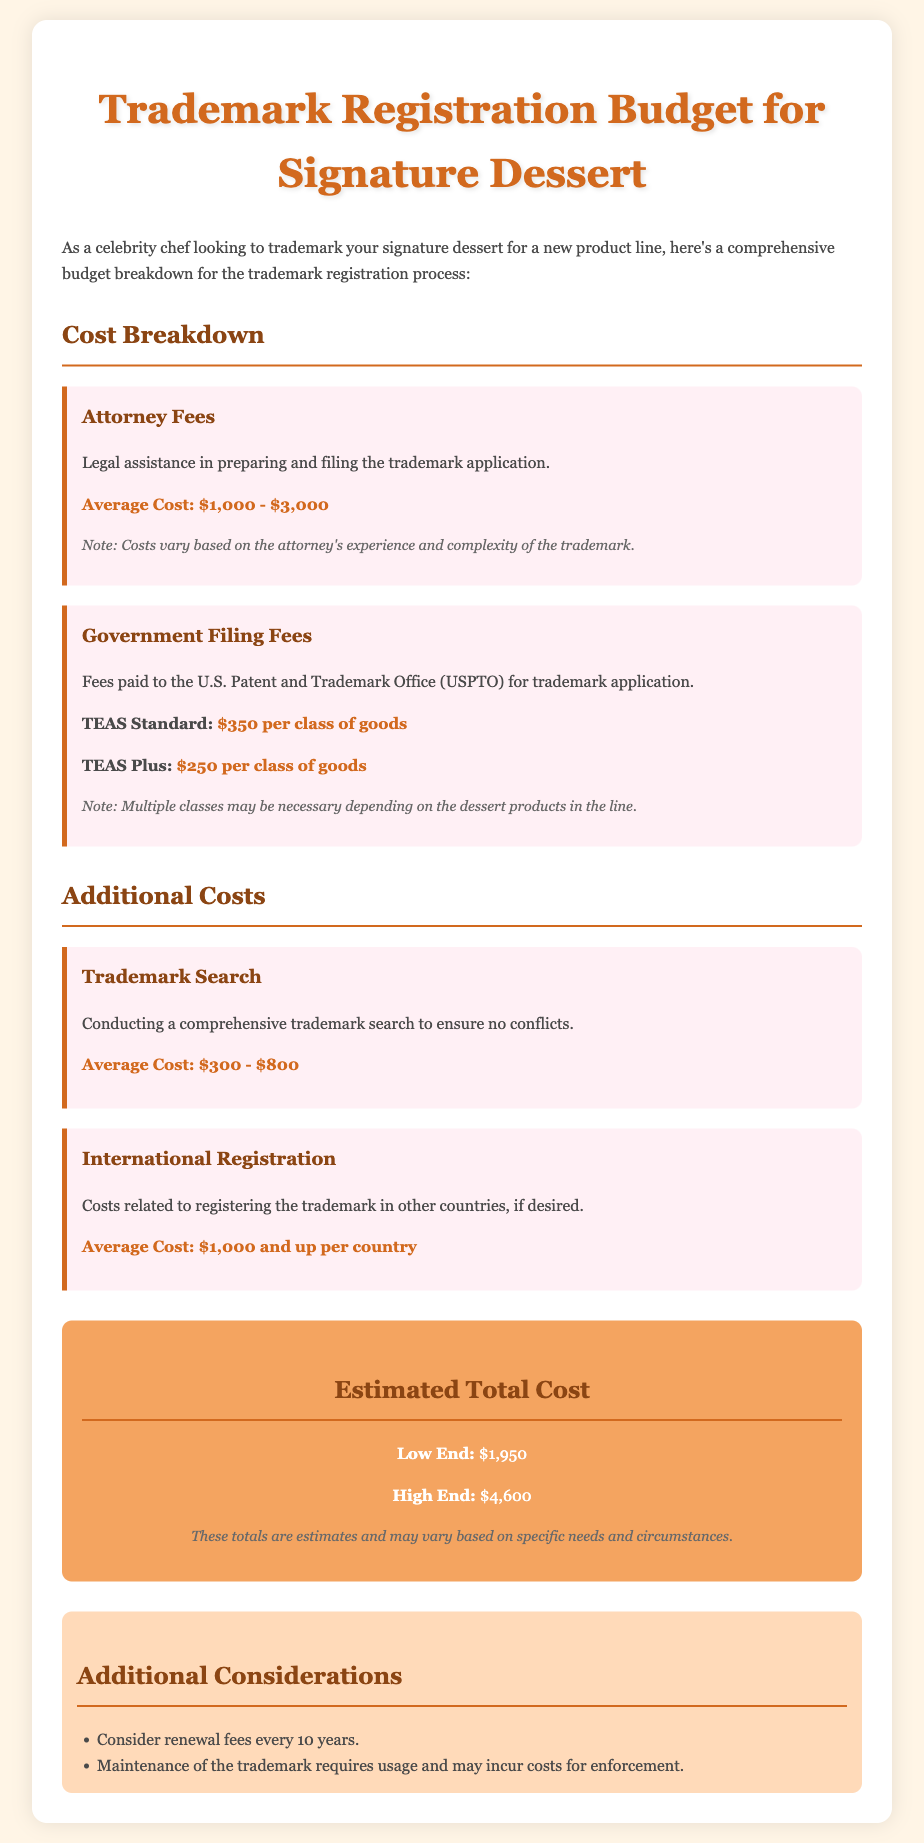What is the average cost for attorney fees? The average attorney fees are mentioned as a range in the document, which is $1,000 - $3,000.
Answer: $1,000 - $3,000 What is the TEAS Plus filing fee per class of goods? The document specifies the TEAS Plus filing fee when referring to government filing fees, which is $250 per class of goods.
Answer: $250 What is the estimated low-end total cost for trademark registration? The document provides estimated total costs, stating that the low-end estimate is $1,950.
Answer: $1,950 What additional cost is associated with conducting a trademark search? The average cost for conducting a trademark search is provided in the document, which is between $300 - $800.
Answer: $300 - $800 What should be considered every 10 years regarding the trademark? The document mentions renewal fees as a consideration that should be noted every 10 years.
Answer: Renewal fees What is the average cost for international registration per country? The document states that the average cost for international registration starts at $1,000 and up per country.
Answer: $1,000 and up How much could the high-end total cost be for trademark registration? The high-end total cost for trademark registration is specified in the document, which is $4,600.
Answer: $4,600 What is the average cost range for conducting a trademark search? The document indicates the average cost range for a trademark search, which is $300 - $800.
Answer: $300 - $800 What may be necessary depending on the dessert products in the line? The document highlights that multiple classes may be necessary for the application based on the dessert products included.
Answer: Multiple classes 